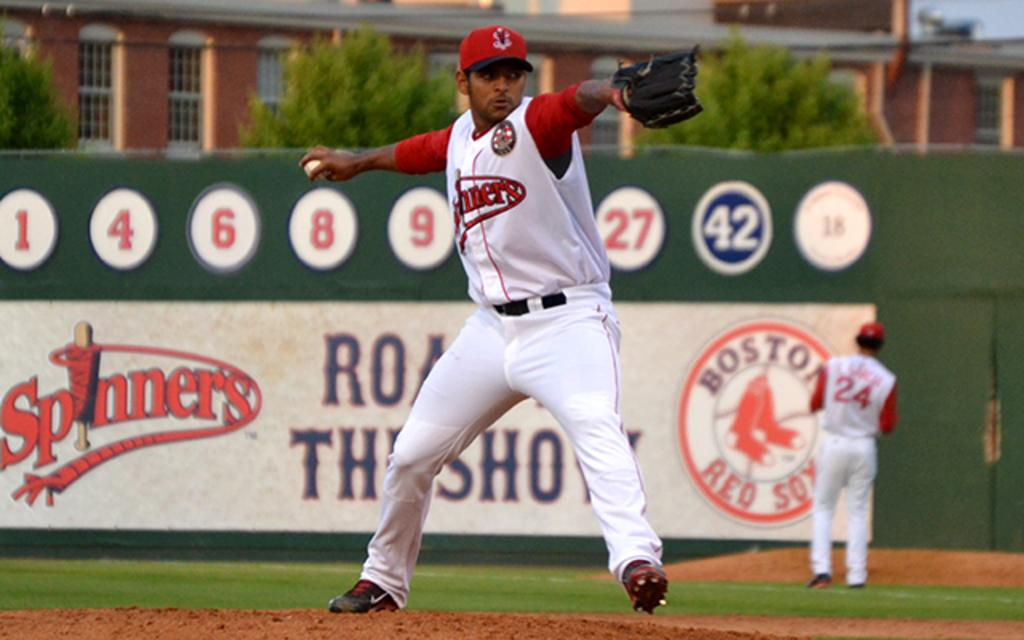<image>
Write a terse but informative summary of the picture. A baseball player is about to throw the ball and the stadium wall behind him says Boston Red Sox. 